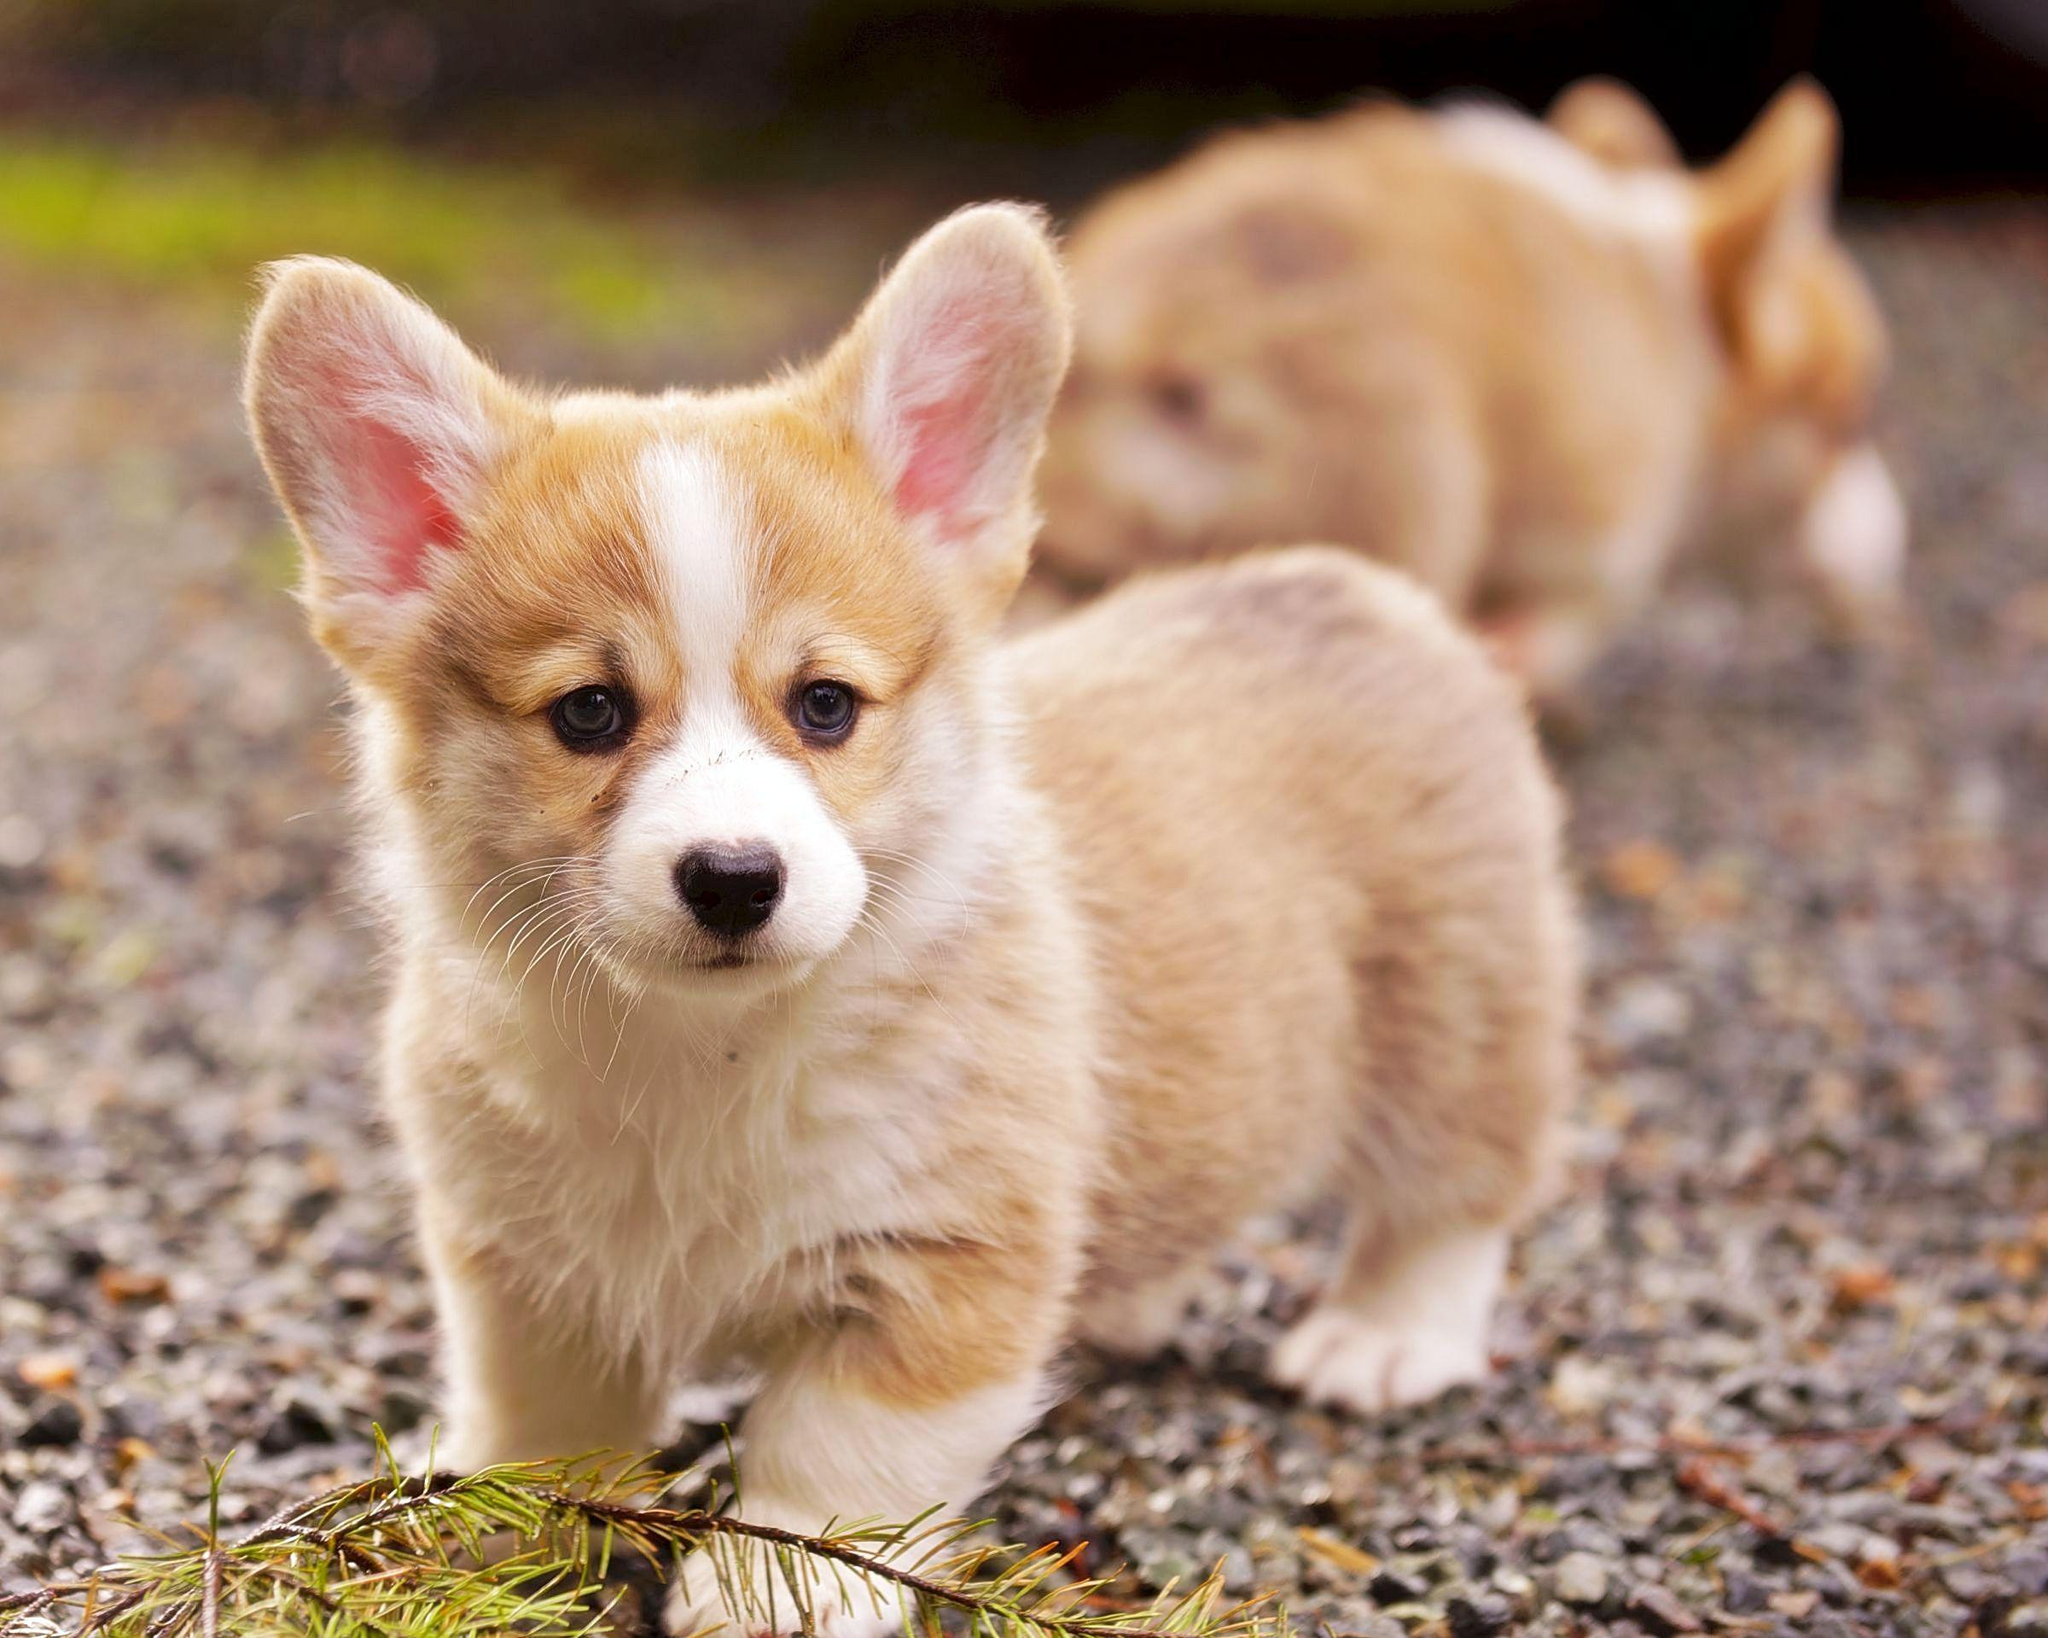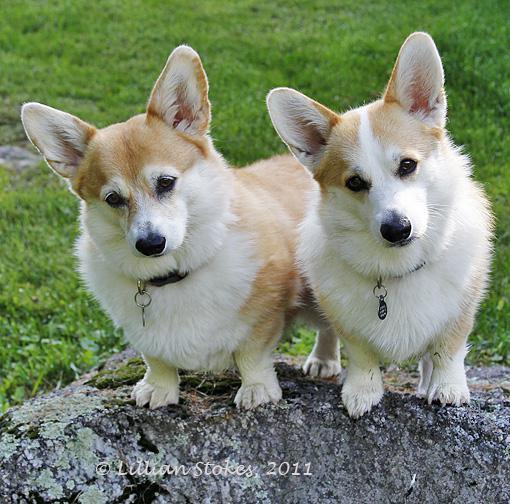The first image is the image on the left, the second image is the image on the right. Considering the images on both sides, is "There is a dog in the left image standing on grass." valid? Answer yes or no. No. 